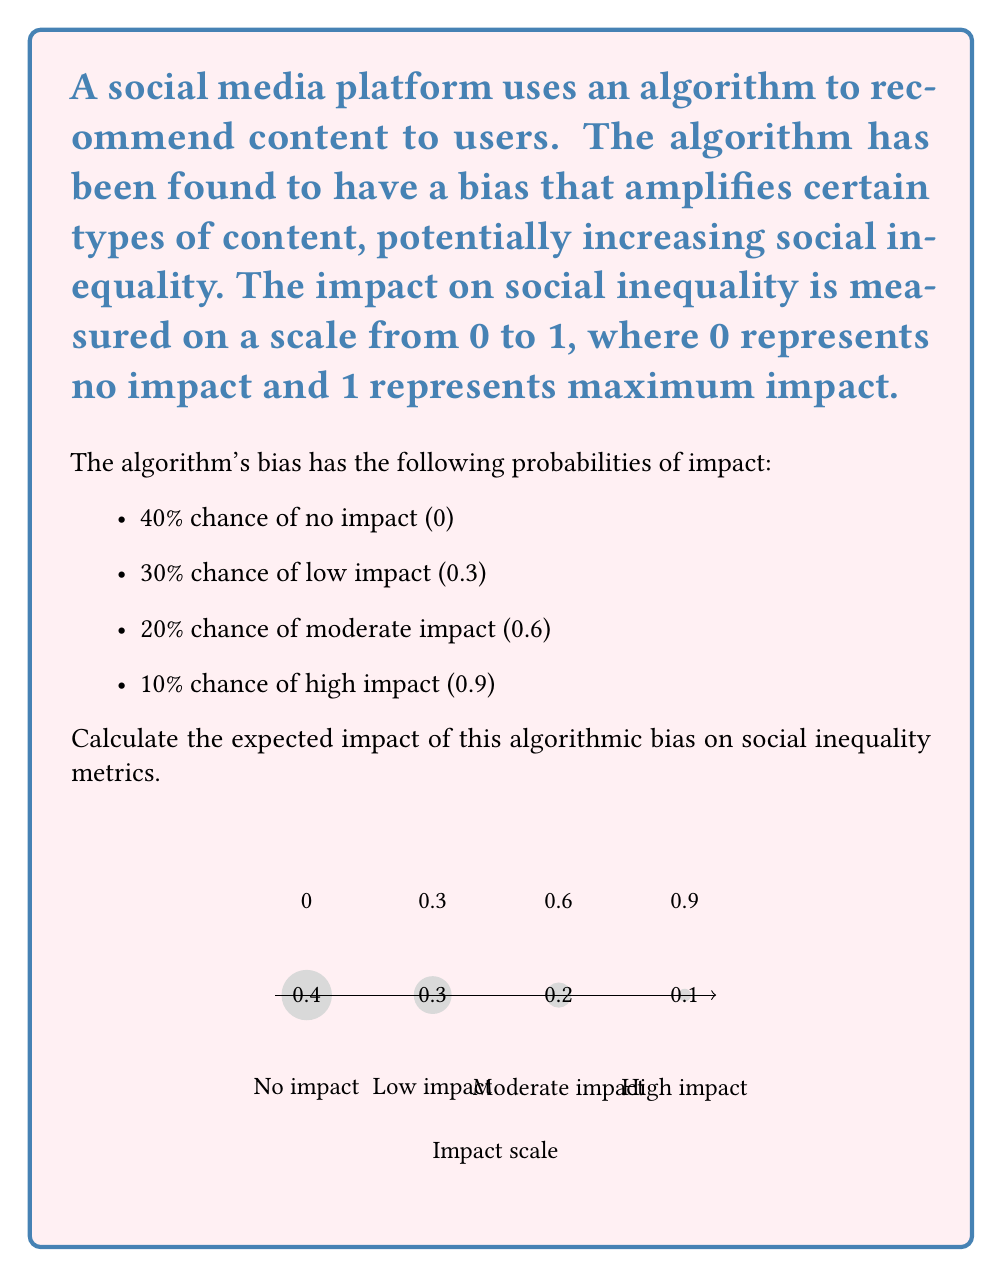Give your solution to this math problem. To calculate the expected impact of the algorithmic bias on social inequality metrics, we need to use the concept of expected value. The expected value is the sum of each possible outcome multiplied by its probability.

Let's break it down step by step:

1) First, let's identify our outcomes and their probabilities:
   - No impact (0): 40% probability = 0.4
   - Low impact (0.3): 30% probability = 0.3
   - Moderate impact (0.6): 20% probability = 0.2
   - High impact (0.9): 10% probability = 0.1

2) Now, let's calculate the expected value using the formula:

   $$ E(X) = \sum_{i=1}^{n} x_i \cdot p(x_i) $$

   Where $x_i$ is the impact value and $p(x_i)$ is its probability.

3) Let's substitute our values:

   $$ E(X) = (0 \cdot 0.4) + (0.3 \cdot 0.3) + (0.6 \cdot 0.2) + (0.9 \cdot 0.1) $$

4) Now, let's calculate each term:
   - $(0 \cdot 0.4) = 0$
   - $(0.3 \cdot 0.3) = 0.09$
   - $(0.6 \cdot 0.2) = 0.12$
   - $(0.9 \cdot 0.1) = 0.09$

5) Sum up all the terms:

   $$ E(X) = 0 + 0.09 + 0.12 + 0.09 = 0.30 $$

Therefore, the expected impact of the algorithmic bias on social inequality metrics is 0.30 on the 0 to 1 scale.
Answer: 0.30 